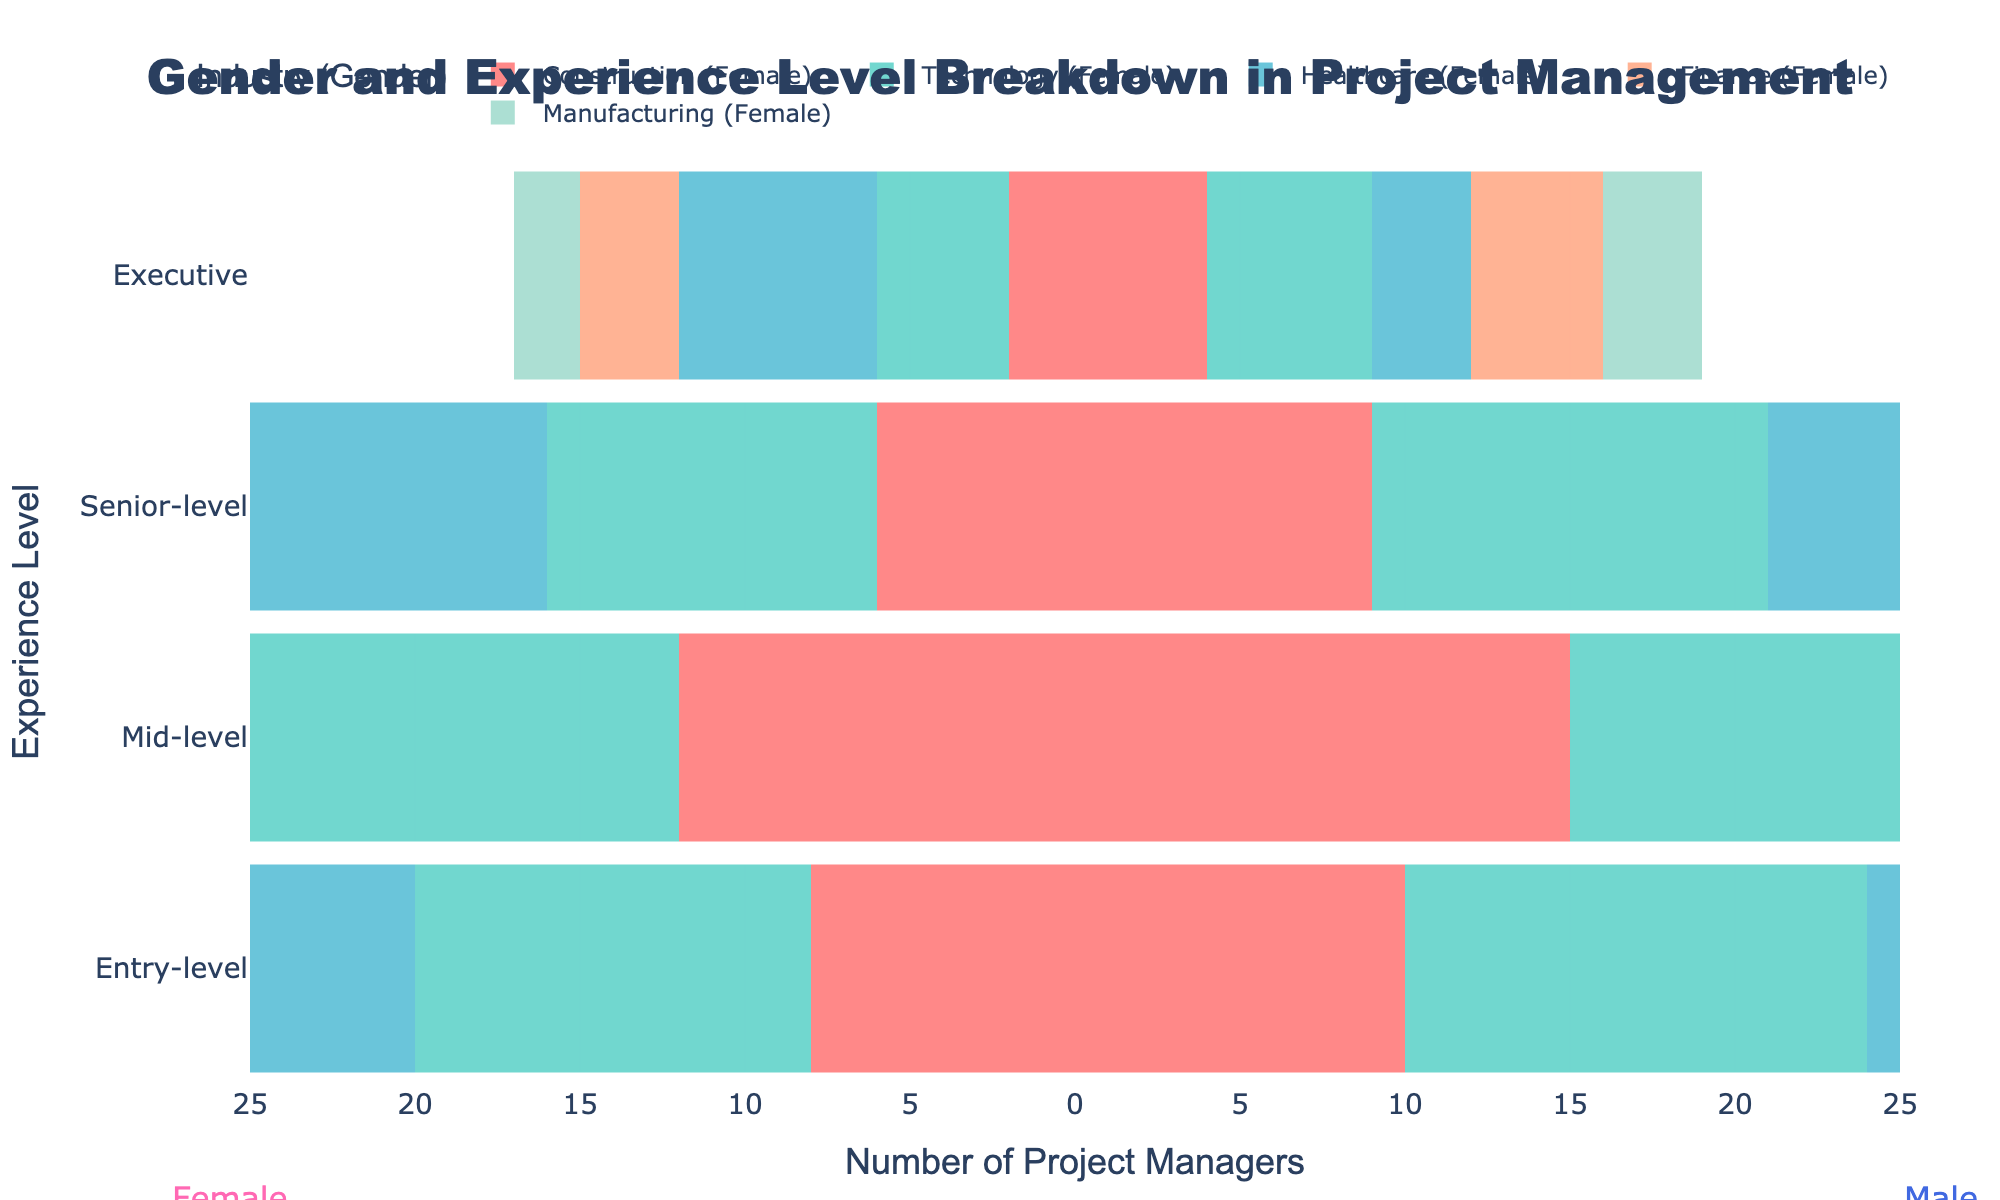what is the highest number of male project managers in the entry-level category? Look for the male data bar in the entry-level category. The highest number of male project managers is in the Technology industry, with a value of 14.
Answer: 14 which industry has the greatest difference in the number of mid-level managers between genders? Calculate the difference for each industry by subtracting the female number from the male number for the mid-level category. The biggest difference is in the Technology industry, with 20 males and 18 females, resulting in a difference of 2.
Answer: Technology how many total senior-level project managers are there in the Healthcare industry? Add the numbers of male and female senior-level project managers in Healthcare. The summary is 14 (female) + 8 (male) = 22.
Answer: 22 in which industry do females have more executive-level managers than males? Compare the number of executive-level managers between genders in each industry. Healthcare and Finance have more female than male executive-level managers (6 females vs. 3 males in Healthcare, 3 females vs. 2 males in Finance).
Answer: Healthcare, Finance what is the ratio of entry-level female managers to male managers in the Construction industry? Look at the entry-level category in Construction. There are 8 female managers and 10 male managers. The ratio is 8:10 or simplified to 4:5.
Answer: 4:5 which experience level shows the biggest overall gender disparity in the Manufacturing industry? Examine all experience levels in Manufacturing and find the differences: Entry-level (7 females, 9 males: difference 2), Mid-level (11 females, 14 males: difference 3), Senior-level (5 females, 8 males: difference 3), Executive (2 females, 3 males: difference 1). So, Mid-level and Senior-level show the biggest disparity, with a difference of 3 each.
Answer: Mid-level, Senior-level what is the proportion of senior-level female to male managers in the Technology industry? Find the senior-level category in Technology. There are 10 females and 12 males. The ratio is 10:12 or simplified to 5:6.
Answer: 5:6 how does the number of mid-level managers in Finance compare between genders? In Finance, the number of mid-level project managers is 16 for females and 18 for males.
Answer: 16 females versus 18 males which gender dominates the executive level in Technology? Check the number of executive-level project managers in Technology. There are 5 males and 4 females, hence males dominate here.
Answer: Males what is the total number of project managers (across all levels and industries) for each gender? Sum up all numbers for each gender across all experience levels and industries: Females (8+12+15+10+7 + 12+18+22+16+11 + 6+10+14+9+5 + 2+4+6+3+2 = 182), and Males (10+14+11+12+9 + 15+20+17+18+14 + 9+12+8+11+8 + 4+5+3+4+3 = 195).
Answer: Females: 182, Males: 195 